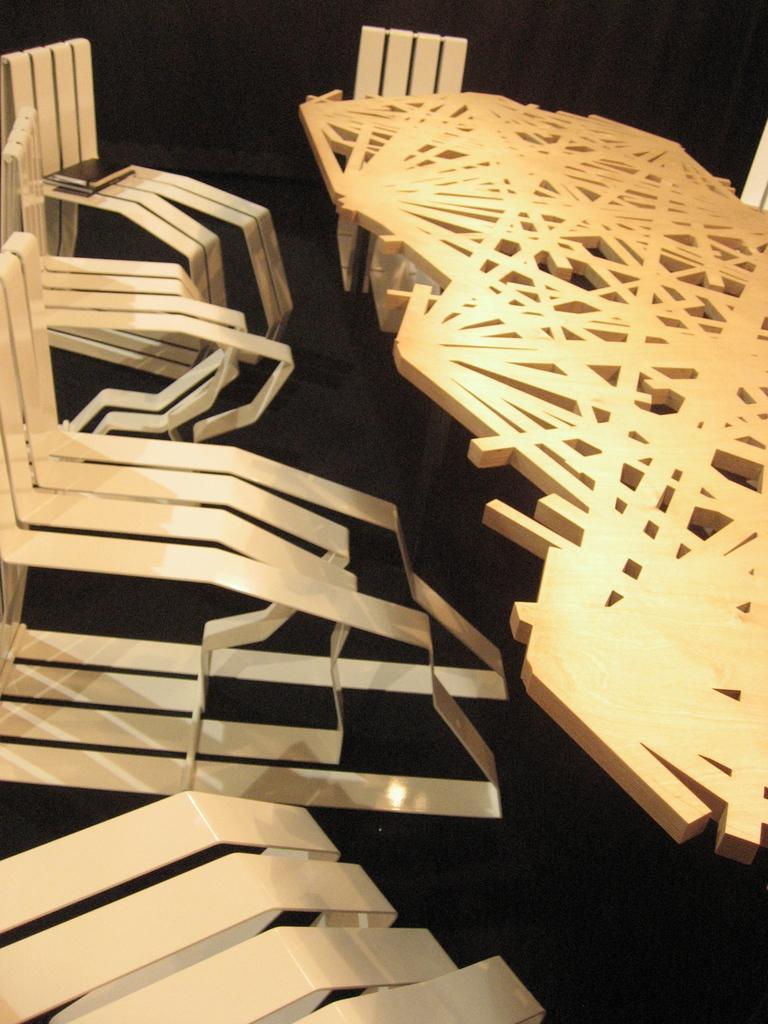Can you describe this image briefly? In this image, we can see a table and some designed chairs. 